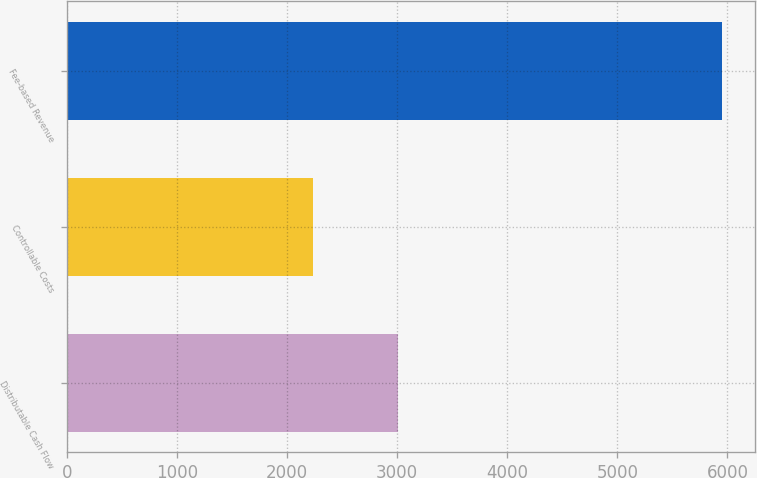Convert chart to OTSL. <chart><loc_0><loc_0><loc_500><loc_500><bar_chart><fcel>Distributable Cash Flow<fcel>Controllable Costs<fcel>Fee-based Revenue<nl><fcel>3010<fcel>2237<fcel>5951<nl></chart> 